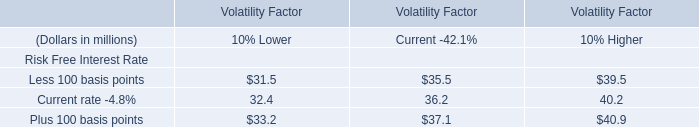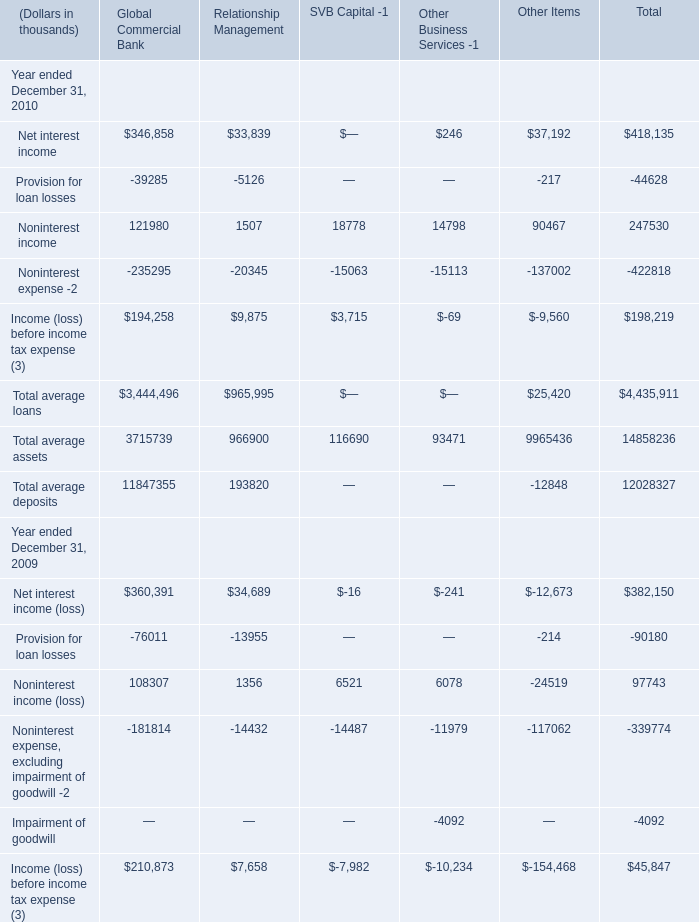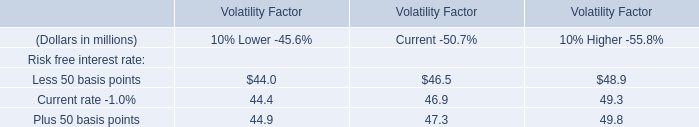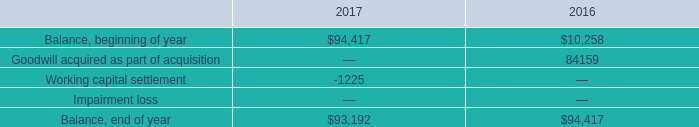What's the average of Noninterest income of Other Items, and Balance, beginning of year of 2017 ? 
Computations: ((90467.0 + 94417.0) / 2)
Answer: 92442.0. 